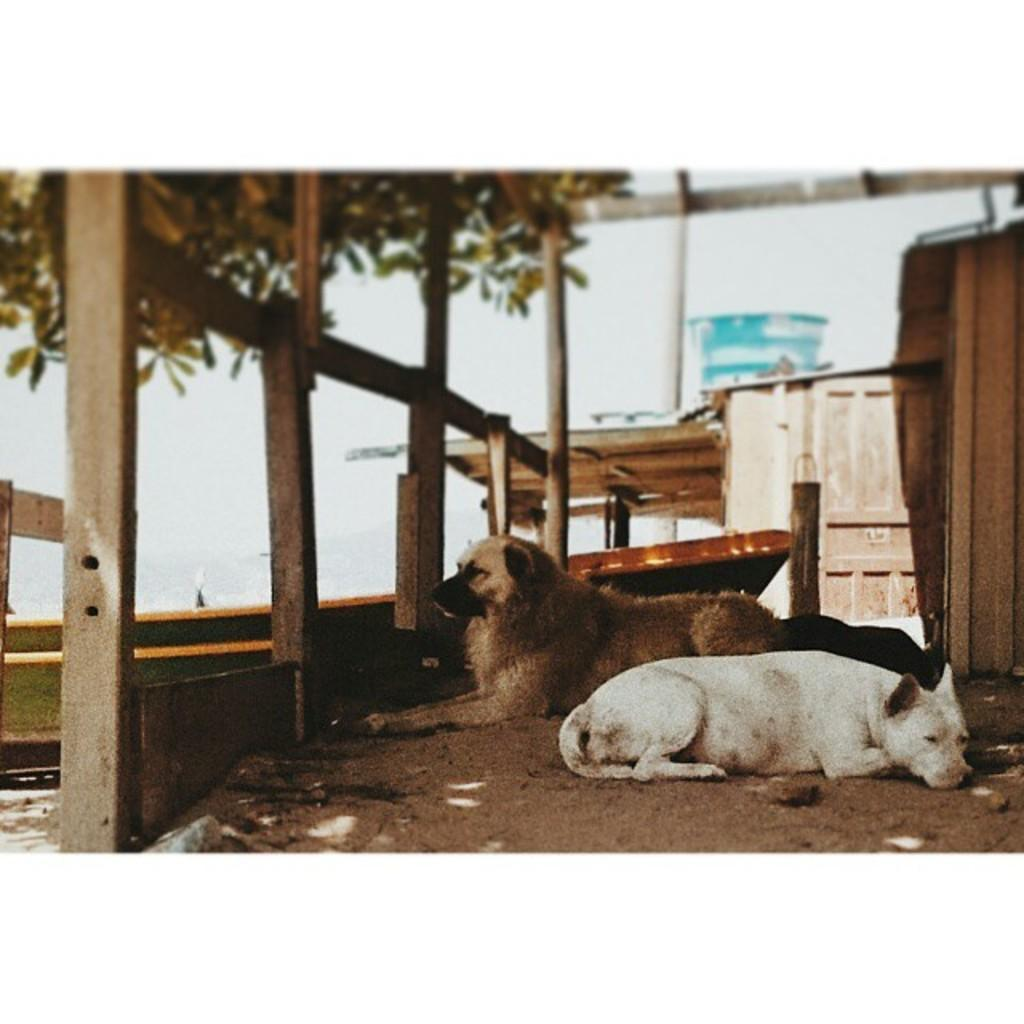How many dogs are present in the image? There are two dogs in the image. What are the dogs doing in the image? The dogs are lying on the soil. What can be seen in the background of the image? There are wooden boxes in the backdrop of the image. What type of structure is visible in the image? There is a building in the image. Where is the kitty hiding in the image? There is no kitty present in the image. What country is the image taken in? The provided facts do not mention the country where the image was taken. 